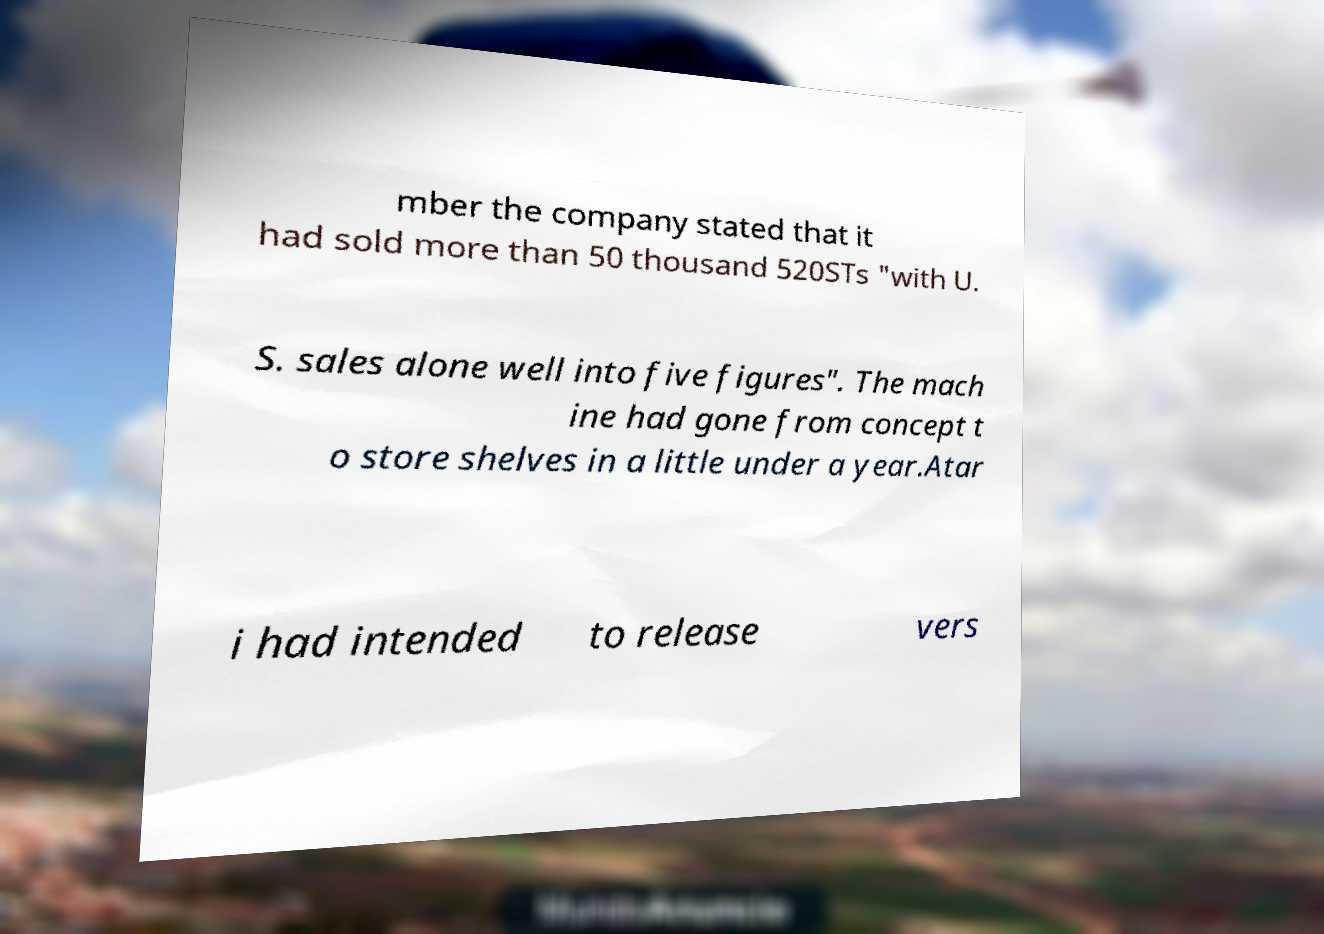Can you accurately transcribe the text from the provided image for me? mber the company stated that it had sold more than 50 thousand 520STs "with U. S. sales alone well into five figures". The mach ine had gone from concept t o store shelves in a little under a year.Atar i had intended to release vers 